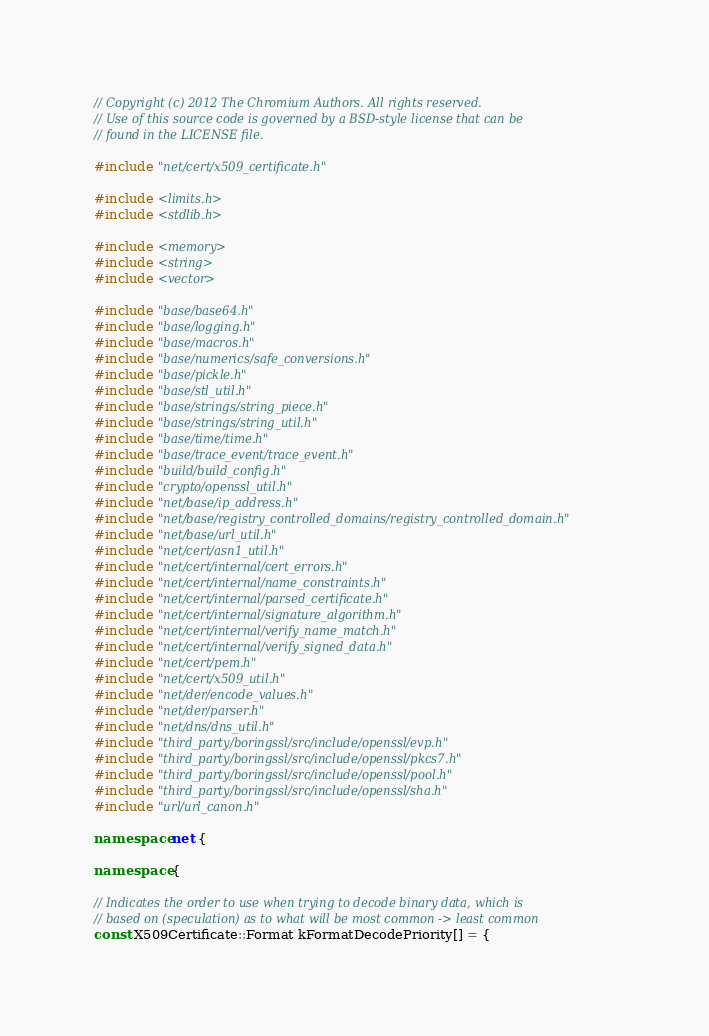Convert code to text. <code><loc_0><loc_0><loc_500><loc_500><_C++_>// Copyright (c) 2012 The Chromium Authors. All rights reserved.
// Use of this source code is governed by a BSD-style license that can be
// found in the LICENSE file.

#include "net/cert/x509_certificate.h"

#include <limits.h>
#include <stdlib.h>

#include <memory>
#include <string>
#include <vector>

#include "base/base64.h"
#include "base/logging.h"
#include "base/macros.h"
#include "base/numerics/safe_conversions.h"
#include "base/pickle.h"
#include "base/stl_util.h"
#include "base/strings/string_piece.h"
#include "base/strings/string_util.h"
#include "base/time/time.h"
#include "base/trace_event/trace_event.h"
#include "build/build_config.h"
#include "crypto/openssl_util.h"
#include "net/base/ip_address.h"
#include "net/base/registry_controlled_domains/registry_controlled_domain.h"
#include "net/base/url_util.h"
#include "net/cert/asn1_util.h"
#include "net/cert/internal/cert_errors.h"
#include "net/cert/internal/name_constraints.h"
#include "net/cert/internal/parsed_certificate.h"
#include "net/cert/internal/signature_algorithm.h"
#include "net/cert/internal/verify_name_match.h"
#include "net/cert/internal/verify_signed_data.h"
#include "net/cert/pem.h"
#include "net/cert/x509_util.h"
#include "net/der/encode_values.h"
#include "net/der/parser.h"
#include "net/dns/dns_util.h"
#include "third_party/boringssl/src/include/openssl/evp.h"
#include "third_party/boringssl/src/include/openssl/pkcs7.h"
#include "third_party/boringssl/src/include/openssl/pool.h"
#include "third_party/boringssl/src/include/openssl/sha.h"
#include "url/url_canon.h"

namespace net {

namespace {

// Indicates the order to use when trying to decode binary data, which is
// based on (speculation) as to what will be most common -> least common
const X509Certificate::Format kFormatDecodePriority[] = {</code> 